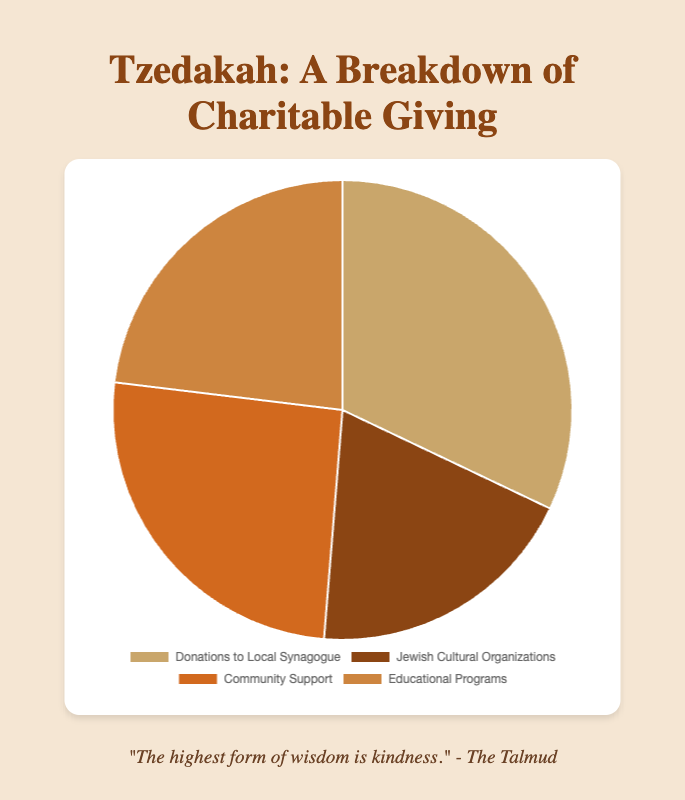What is the total amount donated across all categories? To find the total amount, sum all the donations: 2500 (Local Synagogue) + 1500 (Cultural Organizations) + 2000 (Community Support) + 1800 (Educational Programs) = 7800
Answer: 7800 Which category received the highest donation? Compare the amounts of each category: Local Synagogue (2500), Cultural Organizations (1500), Community Support (2000), Educational Programs (1800). The highest value is 2500 for Local Synagogue.
Answer: Local Synagogue What is the difference between the highest and lowest donations? The highest donation is 2500 (Local Synagogue), and the lowest is 1500 (Cultural Organizations). Difference: 2500 - 1500 = 1000
Answer: 1000 Which categories received more than $1800 in donations? Compare each category's donation to $1800: Local Synagogue (2500 > 1800), Cultural Organizations (1500 < 1800), Community Support (2000 > 1800), Educational Programs (1800 == 1800). Local Synagogue and Community Support received more than $1800.
Answer: Local Synagogue and Community Support Which category is represented by the color brown? Observing the color scheme, brown corresponds to the second color in the list, which represents Jewish Cultural Organizations
Answer: Jewish Cultural Organizations What percentage of the total donations went to Community Support? First, find the total donations: 7800. Then, calculate the percentage for Community Support: (2000 / 7800) * 100 ≈ 25.64%
Answer: 25.64% What are the colors representing Donations to Local Synagogue and Educational Programs? Observing the color scheme, the first color represents Donations to Local Synagogue (a shade of brown), and the fourth color represents Educational Programs (another shade of brown, but darker)
Answer: Shades of brown How much more was donated to Local Synagogue compared to Educational Programs? Local Synagogue received 2500 and Educational Programs received 1800. Difference: 2500 - 1800 = 700
Answer: 700 